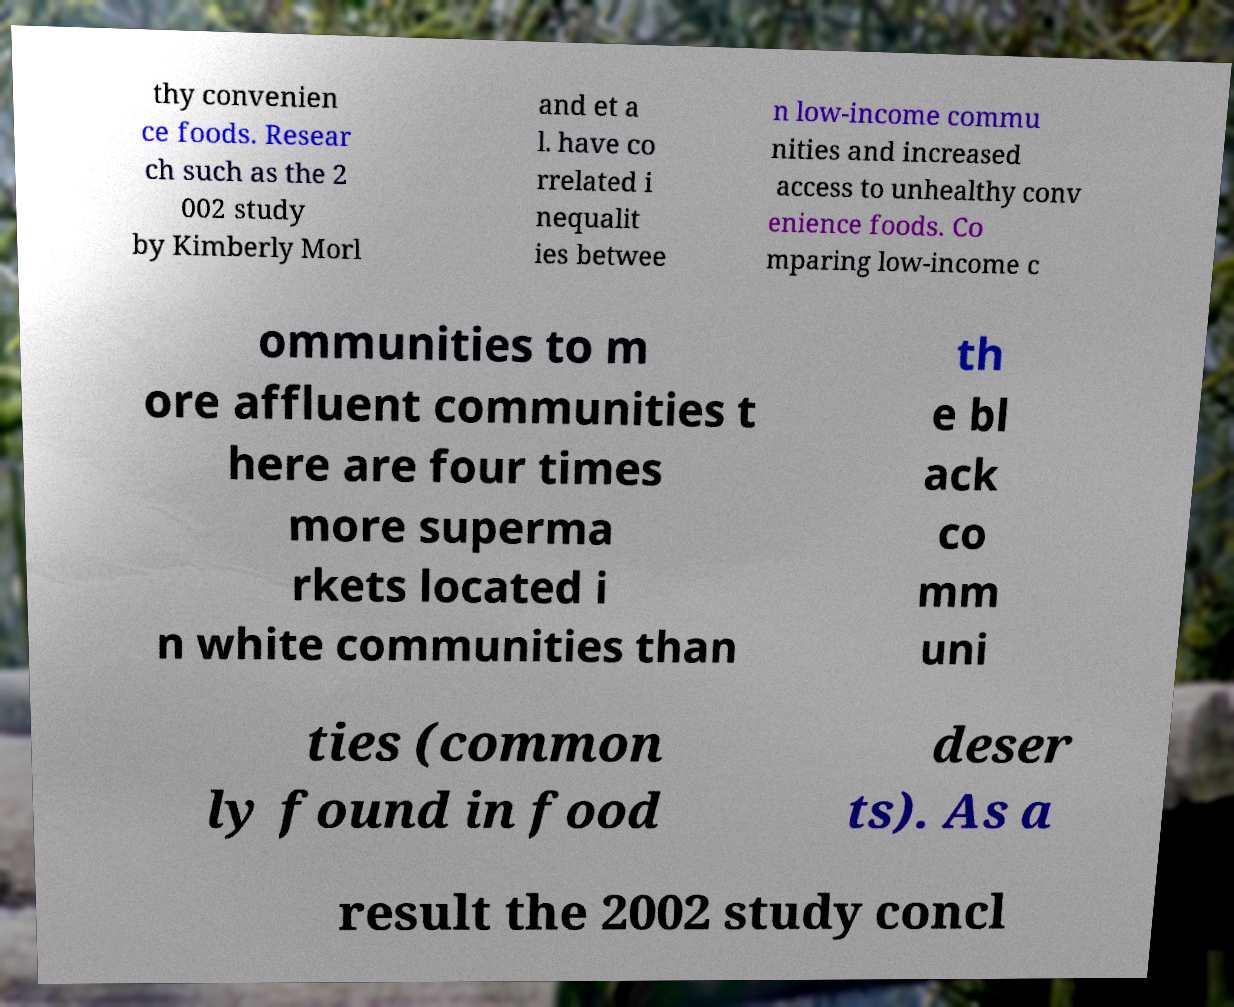Could you assist in decoding the text presented in this image and type it out clearly? thy convenien ce foods. Resear ch such as the 2 002 study by Kimberly Morl and et a l. have co rrelated i nequalit ies betwee n low-income commu nities and increased access to unhealthy conv enience foods. Co mparing low-income c ommunities to m ore affluent communities t here are four times more superma rkets located i n white communities than th e bl ack co mm uni ties (common ly found in food deser ts). As a result the 2002 study concl 